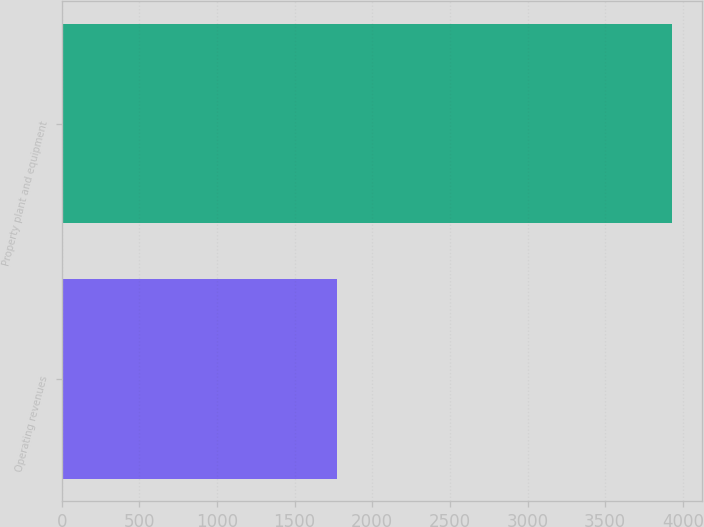<chart> <loc_0><loc_0><loc_500><loc_500><bar_chart><fcel>Operating revenues<fcel>Property plant and equipment<nl><fcel>1771<fcel>3930<nl></chart> 